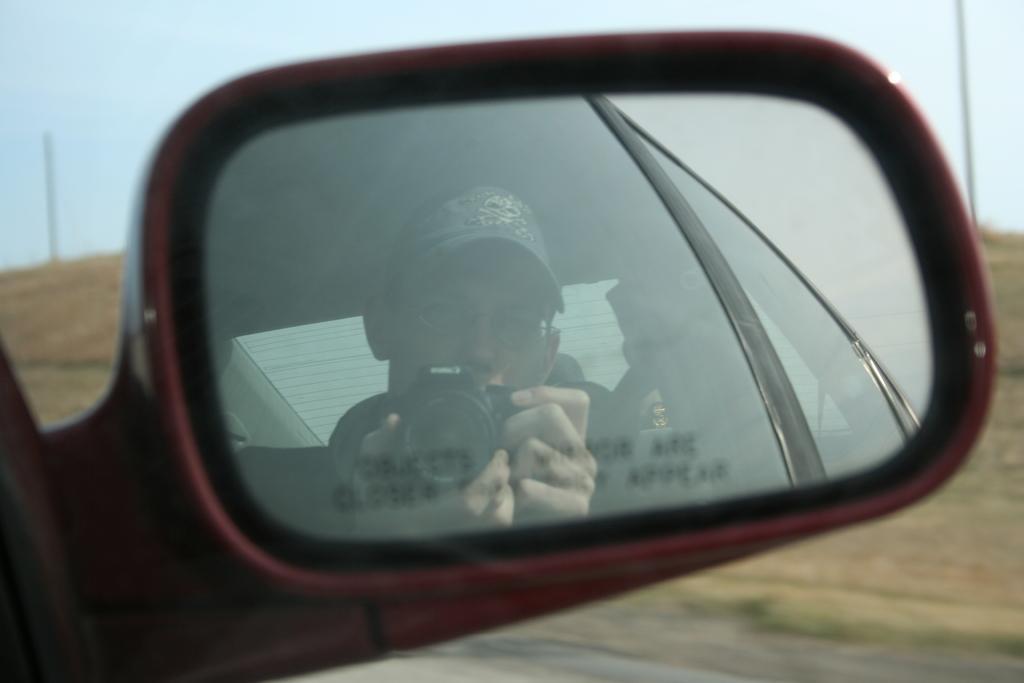Can you describe this image briefly? In this image there is a reflection of a person holding a camera on the side mirror of a car. 